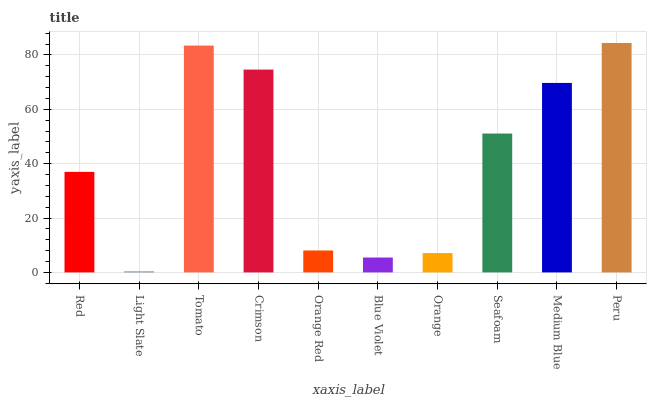Is Tomato the minimum?
Answer yes or no. No. Is Tomato the maximum?
Answer yes or no. No. Is Tomato greater than Light Slate?
Answer yes or no. Yes. Is Light Slate less than Tomato?
Answer yes or no. Yes. Is Light Slate greater than Tomato?
Answer yes or no. No. Is Tomato less than Light Slate?
Answer yes or no. No. Is Seafoam the high median?
Answer yes or no. Yes. Is Red the low median?
Answer yes or no. Yes. Is Light Slate the high median?
Answer yes or no. No. Is Orange the low median?
Answer yes or no. No. 